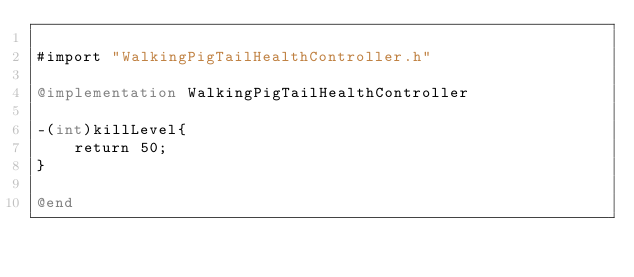Convert code to text. <code><loc_0><loc_0><loc_500><loc_500><_ObjectiveC_>
#import "WalkingPigTailHealthController.h"

@implementation WalkingPigTailHealthController

-(int)killLevel{
    return 50;
}

@end
</code> 